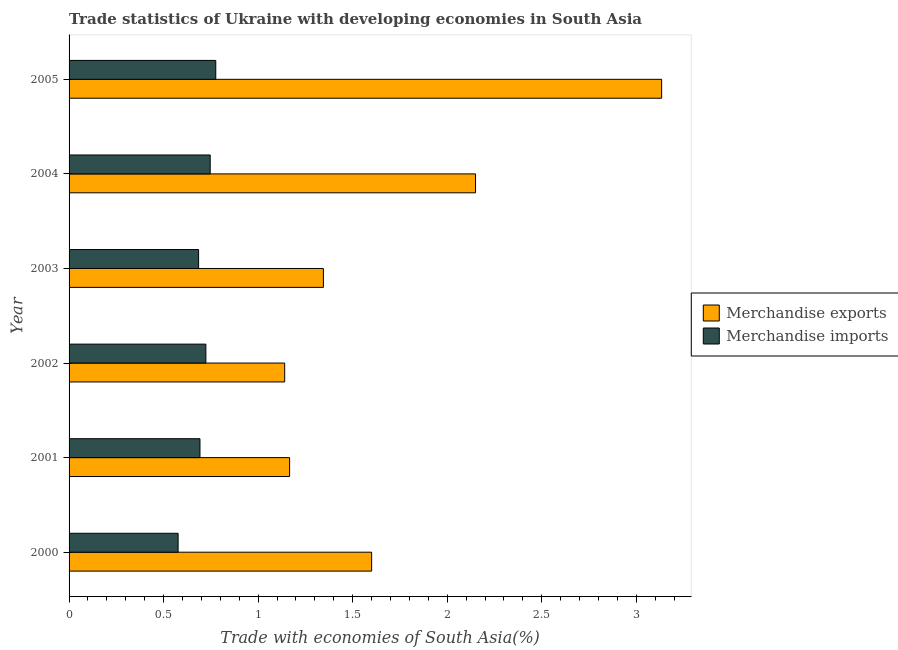Are the number of bars per tick equal to the number of legend labels?
Provide a short and direct response. Yes. Are the number of bars on each tick of the Y-axis equal?
Your response must be concise. Yes. How many bars are there on the 2nd tick from the top?
Make the answer very short. 2. How many bars are there on the 3rd tick from the bottom?
Give a very brief answer. 2. What is the merchandise imports in 2005?
Give a very brief answer. 0.78. Across all years, what is the maximum merchandise imports?
Your response must be concise. 0.78. Across all years, what is the minimum merchandise exports?
Keep it short and to the point. 1.14. In which year was the merchandise exports maximum?
Provide a succinct answer. 2005. What is the total merchandise imports in the graph?
Your answer should be compact. 4.2. What is the difference between the merchandise exports in 2002 and that in 2003?
Give a very brief answer. -0.2. What is the difference between the merchandise imports in 2000 and the merchandise exports in 2003?
Keep it short and to the point. -0.77. What is the average merchandise imports per year?
Your response must be concise. 0.7. In the year 2005, what is the difference between the merchandise exports and merchandise imports?
Your answer should be very brief. 2.36. In how many years, is the merchandise imports greater than 2.7 %?
Your response must be concise. 0. What is the ratio of the merchandise exports in 2001 to that in 2002?
Provide a short and direct response. 1.02. Is the merchandise imports in 2001 less than that in 2003?
Offer a very short reply. No. Is the difference between the merchandise exports in 2004 and 2005 greater than the difference between the merchandise imports in 2004 and 2005?
Offer a terse response. No. What is the difference between the highest and the second highest merchandise imports?
Your response must be concise. 0.03. What is the difference between the highest and the lowest merchandise exports?
Your response must be concise. 1.99. What does the 1st bar from the bottom in 2000 represents?
Make the answer very short. Merchandise exports. Are all the bars in the graph horizontal?
Make the answer very short. Yes. Does the graph contain any zero values?
Make the answer very short. No. How are the legend labels stacked?
Ensure brevity in your answer.  Vertical. What is the title of the graph?
Ensure brevity in your answer.  Trade statistics of Ukraine with developing economies in South Asia. What is the label or title of the X-axis?
Offer a terse response. Trade with economies of South Asia(%). What is the Trade with economies of South Asia(%) of Merchandise exports in 2000?
Give a very brief answer. 1.6. What is the Trade with economies of South Asia(%) of Merchandise imports in 2000?
Your response must be concise. 0.58. What is the Trade with economies of South Asia(%) of Merchandise exports in 2001?
Provide a short and direct response. 1.17. What is the Trade with economies of South Asia(%) of Merchandise imports in 2001?
Offer a very short reply. 0.69. What is the Trade with economies of South Asia(%) of Merchandise exports in 2002?
Keep it short and to the point. 1.14. What is the Trade with economies of South Asia(%) in Merchandise imports in 2002?
Ensure brevity in your answer.  0.72. What is the Trade with economies of South Asia(%) in Merchandise exports in 2003?
Provide a short and direct response. 1.35. What is the Trade with economies of South Asia(%) of Merchandise imports in 2003?
Offer a very short reply. 0.69. What is the Trade with economies of South Asia(%) of Merchandise exports in 2004?
Make the answer very short. 2.15. What is the Trade with economies of South Asia(%) of Merchandise imports in 2004?
Keep it short and to the point. 0.75. What is the Trade with economies of South Asia(%) in Merchandise exports in 2005?
Make the answer very short. 3.13. What is the Trade with economies of South Asia(%) in Merchandise imports in 2005?
Offer a very short reply. 0.78. Across all years, what is the maximum Trade with economies of South Asia(%) in Merchandise exports?
Your response must be concise. 3.13. Across all years, what is the maximum Trade with economies of South Asia(%) of Merchandise imports?
Offer a very short reply. 0.78. Across all years, what is the minimum Trade with economies of South Asia(%) of Merchandise exports?
Ensure brevity in your answer.  1.14. Across all years, what is the minimum Trade with economies of South Asia(%) of Merchandise imports?
Your response must be concise. 0.58. What is the total Trade with economies of South Asia(%) of Merchandise exports in the graph?
Provide a short and direct response. 10.54. What is the total Trade with economies of South Asia(%) in Merchandise imports in the graph?
Offer a very short reply. 4.2. What is the difference between the Trade with economies of South Asia(%) of Merchandise exports in 2000 and that in 2001?
Your response must be concise. 0.43. What is the difference between the Trade with economies of South Asia(%) of Merchandise imports in 2000 and that in 2001?
Offer a terse response. -0.12. What is the difference between the Trade with economies of South Asia(%) of Merchandise exports in 2000 and that in 2002?
Give a very brief answer. 0.46. What is the difference between the Trade with economies of South Asia(%) of Merchandise imports in 2000 and that in 2002?
Provide a short and direct response. -0.15. What is the difference between the Trade with economies of South Asia(%) of Merchandise exports in 2000 and that in 2003?
Offer a very short reply. 0.26. What is the difference between the Trade with economies of South Asia(%) in Merchandise imports in 2000 and that in 2003?
Keep it short and to the point. -0.11. What is the difference between the Trade with economies of South Asia(%) of Merchandise exports in 2000 and that in 2004?
Offer a very short reply. -0.55. What is the difference between the Trade with economies of South Asia(%) of Merchandise imports in 2000 and that in 2004?
Provide a short and direct response. -0.17. What is the difference between the Trade with economies of South Asia(%) of Merchandise exports in 2000 and that in 2005?
Your answer should be compact. -1.53. What is the difference between the Trade with economies of South Asia(%) of Merchandise imports in 2000 and that in 2005?
Ensure brevity in your answer.  -0.2. What is the difference between the Trade with economies of South Asia(%) in Merchandise exports in 2001 and that in 2002?
Offer a terse response. 0.03. What is the difference between the Trade with economies of South Asia(%) of Merchandise imports in 2001 and that in 2002?
Give a very brief answer. -0.03. What is the difference between the Trade with economies of South Asia(%) in Merchandise exports in 2001 and that in 2003?
Ensure brevity in your answer.  -0.18. What is the difference between the Trade with economies of South Asia(%) in Merchandise imports in 2001 and that in 2003?
Offer a very short reply. 0.01. What is the difference between the Trade with economies of South Asia(%) in Merchandise exports in 2001 and that in 2004?
Ensure brevity in your answer.  -0.98. What is the difference between the Trade with economies of South Asia(%) in Merchandise imports in 2001 and that in 2004?
Make the answer very short. -0.05. What is the difference between the Trade with economies of South Asia(%) in Merchandise exports in 2001 and that in 2005?
Ensure brevity in your answer.  -1.97. What is the difference between the Trade with economies of South Asia(%) of Merchandise imports in 2001 and that in 2005?
Provide a short and direct response. -0.08. What is the difference between the Trade with economies of South Asia(%) of Merchandise exports in 2002 and that in 2003?
Your response must be concise. -0.2. What is the difference between the Trade with economies of South Asia(%) of Merchandise imports in 2002 and that in 2003?
Offer a terse response. 0.04. What is the difference between the Trade with economies of South Asia(%) of Merchandise exports in 2002 and that in 2004?
Offer a very short reply. -1.01. What is the difference between the Trade with economies of South Asia(%) of Merchandise imports in 2002 and that in 2004?
Provide a short and direct response. -0.02. What is the difference between the Trade with economies of South Asia(%) of Merchandise exports in 2002 and that in 2005?
Provide a succinct answer. -1.99. What is the difference between the Trade with economies of South Asia(%) of Merchandise imports in 2002 and that in 2005?
Provide a short and direct response. -0.05. What is the difference between the Trade with economies of South Asia(%) in Merchandise exports in 2003 and that in 2004?
Offer a terse response. -0.8. What is the difference between the Trade with economies of South Asia(%) of Merchandise imports in 2003 and that in 2004?
Ensure brevity in your answer.  -0.06. What is the difference between the Trade with economies of South Asia(%) in Merchandise exports in 2003 and that in 2005?
Your answer should be very brief. -1.79. What is the difference between the Trade with economies of South Asia(%) in Merchandise imports in 2003 and that in 2005?
Provide a short and direct response. -0.09. What is the difference between the Trade with economies of South Asia(%) of Merchandise exports in 2004 and that in 2005?
Your answer should be very brief. -0.98. What is the difference between the Trade with economies of South Asia(%) in Merchandise imports in 2004 and that in 2005?
Your answer should be compact. -0.03. What is the difference between the Trade with economies of South Asia(%) in Merchandise exports in 2000 and the Trade with economies of South Asia(%) in Merchandise imports in 2001?
Provide a succinct answer. 0.91. What is the difference between the Trade with economies of South Asia(%) of Merchandise exports in 2000 and the Trade with economies of South Asia(%) of Merchandise imports in 2002?
Your answer should be very brief. 0.88. What is the difference between the Trade with economies of South Asia(%) in Merchandise exports in 2000 and the Trade with economies of South Asia(%) in Merchandise imports in 2003?
Give a very brief answer. 0.92. What is the difference between the Trade with economies of South Asia(%) in Merchandise exports in 2000 and the Trade with economies of South Asia(%) in Merchandise imports in 2004?
Your answer should be compact. 0.85. What is the difference between the Trade with economies of South Asia(%) in Merchandise exports in 2000 and the Trade with economies of South Asia(%) in Merchandise imports in 2005?
Offer a very short reply. 0.82. What is the difference between the Trade with economies of South Asia(%) of Merchandise exports in 2001 and the Trade with economies of South Asia(%) of Merchandise imports in 2002?
Keep it short and to the point. 0.44. What is the difference between the Trade with economies of South Asia(%) of Merchandise exports in 2001 and the Trade with economies of South Asia(%) of Merchandise imports in 2003?
Keep it short and to the point. 0.48. What is the difference between the Trade with economies of South Asia(%) of Merchandise exports in 2001 and the Trade with economies of South Asia(%) of Merchandise imports in 2004?
Make the answer very short. 0.42. What is the difference between the Trade with economies of South Asia(%) of Merchandise exports in 2001 and the Trade with economies of South Asia(%) of Merchandise imports in 2005?
Your answer should be compact. 0.39. What is the difference between the Trade with economies of South Asia(%) of Merchandise exports in 2002 and the Trade with economies of South Asia(%) of Merchandise imports in 2003?
Your response must be concise. 0.46. What is the difference between the Trade with economies of South Asia(%) of Merchandise exports in 2002 and the Trade with economies of South Asia(%) of Merchandise imports in 2004?
Offer a terse response. 0.39. What is the difference between the Trade with economies of South Asia(%) in Merchandise exports in 2002 and the Trade with economies of South Asia(%) in Merchandise imports in 2005?
Your response must be concise. 0.36. What is the difference between the Trade with economies of South Asia(%) of Merchandise exports in 2003 and the Trade with economies of South Asia(%) of Merchandise imports in 2004?
Offer a very short reply. 0.6. What is the difference between the Trade with economies of South Asia(%) in Merchandise exports in 2003 and the Trade with economies of South Asia(%) in Merchandise imports in 2005?
Ensure brevity in your answer.  0.57. What is the difference between the Trade with economies of South Asia(%) in Merchandise exports in 2004 and the Trade with economies of South Asia(%) in Merchandise imports in 2005?
Your answer should be compact. 1.37. What is the average Trade with economies of South Asia(%) in Merchandise exports per year?
Ensure brevity in your answer.  1.76. What is the average Trade with economies of South Asia(%) in Merchandise imports per year?
Provide a short and direct response. 0.7. In the year 2000, what is the difference between the Trade with economies of South Asia(%) of Merchandise exports and Trade with economies of South Asia(%) of Merchandise imports?
Ensure brevity in your answer.  1.02. In the year 2001, what is the difference between the Trade with economies of South Asia(%) of Merchandise exports and Trade with economies of South Asia(%) of Merchandise imports?
Provide a short and direct response. 0.47. In the year 2002, what is the difference between the Trade with economies of South Asia(%) in Merchandise exports and Trade with economies of South Asia(%) in Merchandise imports?
Make the answer very short. 0.42. In the year 2003, what is the difference between the Trade with economies of South Asia(%) in Merchandise exports and Trade with economies of South Asia(%) in Merchandise imports?
Offer a very short reply. 0.66. In the year 2004, what is the difference between the Trade with economies of South Asia(%) of Merchandise exports and Trade with economies of South Asia(%) of Merchandise imports?
Your answer should be very brief. 1.4. In the year 2005, what is the difference between the Trade with economies of South Asia(%) in Merchandise exports and Trade with economies of South Asia(%) in Merchandise imports?
Give a very brief answer. 2.36. What is the ratio of the Trade with economies of South Asia(%) of Merchandise exports in 2000 to that in 2001?
Offer a very short reply. 1.37. What is the ratio of the Trade with economies of South Asia(%) in Merchandise imports in 2000 to that in 2001?
Your answer should be very brief. 0.83. What is the ratio of the Trade with economies of South Asia(%) of Merchandise exports in 2000 to that in 2002?
Offer a terse response. 1.4. What is the ratio of the Trade with economies of South Asia(%) in Merchandise imports in 2000 to that in 2002?
Your response must be concise. 0.8. What is the ratio of the Trade with economies of South Asia(%) in Merchandise exports in 2000 to that in 2003?
Your response must be concise. 1.19. What is the ratio of the Trade with economies of South Asia(%) in Merchandise imports in 2000 to that in 2003?
Keep it short and to the point. 0.84. What is the ratio of the Trade with economies of South Asia(%) in Merchandise exports in 2000 to that in 2004?
Your answer should be very brief. 0.74. What is the ratio of the Trade with economies of South Asia(%) of Merchandise imports in 2000 to that in 2004?
Ensure brevity in your answer.  0.77. What is the ratio of the Trade with economies of South Asia(%) of Merchandise exports in 2000 to that in 2005?
Provide a short and direct response. 0.51. What is the ratio of the Trade with economies of South Asia(%) of Merchandise imports in 2000 to that in 2005?
Provide a succinct answer. 0.74. What is the ratio of the Trade with economies of South Asia(%) of Merchandise exports in 2001 to that in 2002?
Ensure brevity in your answer.  1.02. What is the ratio of the Trade with economies of South Asia(%) of Merchandise imports in 2001 to that in 2002?
Offer a terse response. 0.96. What is the ratio of the Trade with economies of South Asia(%) of Merchandise exports in 2001 to that in 2003?
Keep it short and to the point. 0.87. What is the ratio of the Trade with economies of South Asia(%) of Merchandise imports in 2001 to that in 2003?
Provide a short and direct response. 1.01. What is the ratio of the Trade with economies of South Asia(%) in Merchandise exports in 2001 to that in 2004?
Your response must be concise. 0.54. What is the ratio of the Trade with economies of South Asia(%) of Merchandise imports in 2001 to that in 2004?
Your response must be concise. 0.93. What is the ratio of the Trade with economies of South Asia(%) of Merchandise exports in 2001 to that in 2005?
Ensure brevity in your answer.  0.37. What is the ratio of the Trade with economies of South Asia(%) of Merchandise imports in 2001 to that in 2005?
Provide a succinct answer. 0.89. What is the ratio of the Trade with economies of South Asia(%) of Merchandise exports in 2002 to that in 2003?
Your response must be concise. 0.85. What is the ratio of the Trade with economies of South Asia(%) of Merchandise imports in 2002 to that in 2003?
Offer a terse response. 1.06. What is the ratio of the Trade with economies of South Asia(%) in Merchandise exports in 2002 to that in 2004?
Your answer should be compact. 0.53. What is the ratio of the Trade with economies of South Asia(%) of Merchandise imports in 2002 to that in 2004?
Provide a short and direct response. 0.97. What is the ratio of the Trade with economies of South Asia(%) in Merchandise exports in 2002 to that in 2005?
Provide a short and direct response. 0.36. What is the ratio of the Trade with economies of South Asia(%) of Merchandise imports in 2002 to that in 2005?
Your response must be concise. 0.93. What is the ratio of the Trade with economies of South Asia(%) of Merchandise exports in 2003 to that in 2004?
Provide a short and direct response. 0.63. What is the ratio of the Trade with economies of South Asia(%) of Merchandise imports in 2003 to that in 2004?
Give a very brief answer. 0.92. What is the ratio of the Trade with economies of South Asia(%) in Merchandise exports in 2003 to that in 2005?
Make the answer very short. 0.43. What is the ratio of the Trade with economies of South Asia(%) in Merchandise imports in 2003 to that in 2005?
Offer a terse response. 0.88. What is the ratio of the Trade with economies of South Asia(%) in Merchandise exports in 2004 to that in 2005?
Give a very brief answer. 0.69. What is the ratio of the Trade with economies of South Asia(%) in Merchandise imports in 2004 to that in 2005?
Make the answer very short. 0.96. What is the difference between the highest and the second highest Trade with economies of South Asia(%) of Merchandise exports?
Offer a very short reply. 0.98. What is the difference between the highest and the second highest Trade with economies of South Asia(%) in Merchandise imports?
Offer a very short reply. 0.03. What is the difference between the highest and the lowest Trade with economies of South Asia(%) in Merchandise exports?
Your response must be concise. 1.99. What is the difference between the highest and the lowest Trade with economies of South Asia(%) of Merchandise imports?
Your answer should be compact. 0.2. 